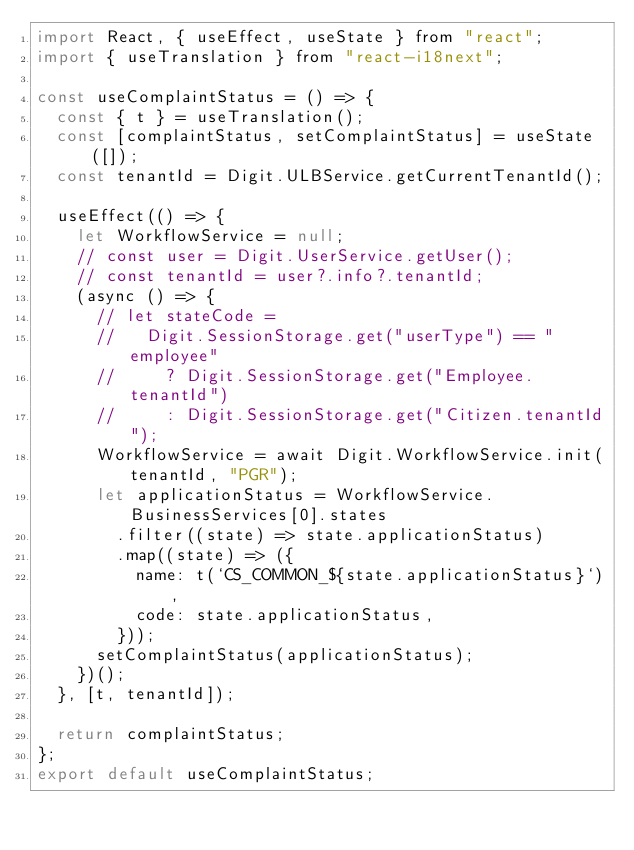<code> <loc_0><loc_0><loc_500><loc_500><_JavaScript_>import React, { useEffect, useState } from "react";
import { useTranslation } from "react-i18next";

const useComplaintStatus = () => {
  const { t } = useTranslation();
  const [complaintStatus, setComplaintStatus] = useState([]);
  const tenantId = Digit.ULBService.getCurrentTenantId();

  useEffect(() => {
    let WorkflowService = null;
    // const user = Digit.UserService.getUser();
    // const tenantId = user?.info?.tenantId;
    (async () => {
      // let stateCode =
      //   Digit.SessionStorage.get("userType") == "employee"
      //     ? Digit.SessionStorage.get("Employee.tenantId")
      //     : Digit.SessionStorage.get("Citizen.tenantId");
      WorkflowService = await Digit.WorkflowService.init(tenantId, "PGR");
      let applicationStatus = WorkflowService.BusinessServices[0].states
        .filter((state) => state.applicationStatus)
        .map((state) => ({
          name: t(`CS_COMMON_${state.applicationStatus}`),
          code: state.applicationStatus,
        }));
      setComplaintStatus(applicationStatus);
    })();
  }, [t, tenantId]);

  return complaintStatus;
};
export default useComplaintStatus;
</code> 